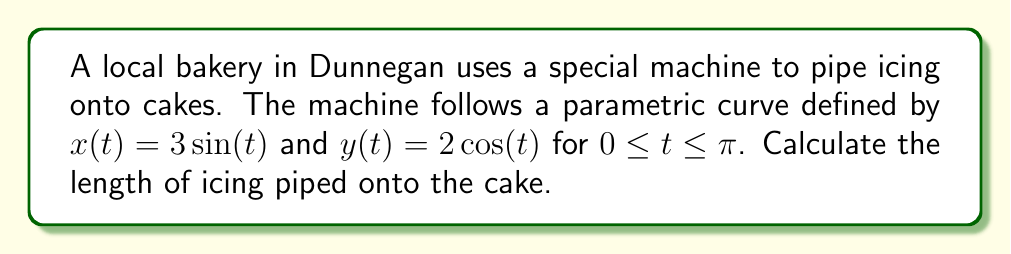Teach me how to tackle this problem. To find the arc length of a parametric curve, we use the formula:

$$L = \int_{a}^{b} \sqrt{\left(\frac{dx}{dt}\right)^2 + \left(\frac{dy}{dt}\right)^2} dt$$

Step 1: Find $\frac{dx}{dt}$ and $\frac{dy}{dt}$
$\frac{dx}{dt} = 3\cos(t)$
$\frac{dy}{dt} = -2\sin(t)$

Step 2: Substitute into the formula
$$L = \int_{0}^{\pi} \sqrt{(3\cos(t))^2 + (-2\sin(t))^2} dt$$

Step 3: Simplify under the square root
$$L = \int_{0}^{\pi} \sqrt{9\cos^2(t) + 4\sin^2(t)} dt$$

Step 4: Use the identity $\cos^2(t) + \sin^2(t) = 1$
$$L = \int_{0}^{\pi} \sqrt{9(\cos^2(t) + \sin^2(t)) - 5\sin^2(t)} dt$$
$$L = \int_{0}^{\pi} \sqrt{9 - 5\sin^2(t)} dt$$

Step 5: Substitute $u = \sin(t)$, $du = \cos(t)dt$
$$L = \int_{0}^{1} \sqrt{9 - 5u^2} \frac{du}{\sqrt{1-u^2}}$$

Step 6: This integral simplifies to an elliptic integral of the second kind
$$L = 3E\left(\frac{\pi}{2}, \frac{\sqrt{5}}{3}\right)$$

Where $E$ is the complete elliptic integral of the second kind.
Answer: $3E\left(\frac{\pi}{2}, \frac{\sqrt{5}}{3}\right)$ 